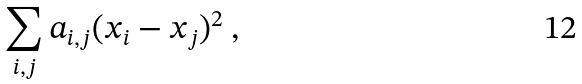<formula> <loc_0><loc_0><loc_500><loc_500>\sum _ { i , j } a _ { i , j } ( x _ { i } - x _ { j } ) ^ { 2 } \ ,</formula> 